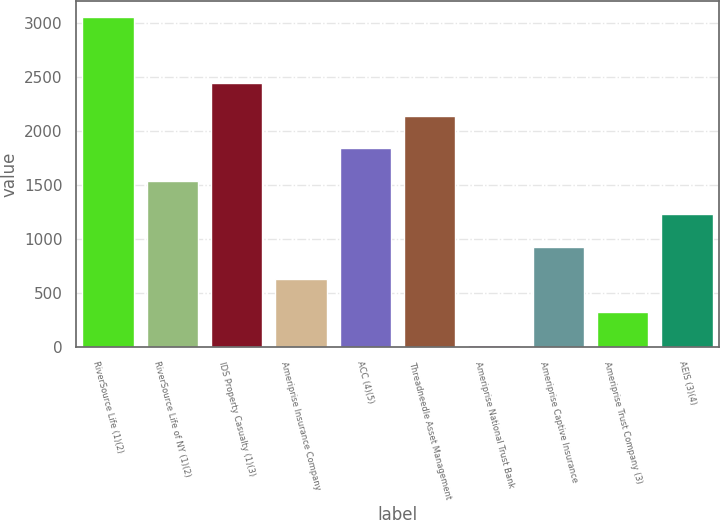<chart> <loc_0><loc_0><loc_500><loc_500><bar_chart><fcel>RiverSource Life (1)(2)<fcel>RiverSource Life of NY (1)(2)<fcel>IDS Property Casualty (1)(3)<fcel>Ameriprise Insurance Company<fcel>ACC (4)(5)<fcel>Threadneedle Asset Management<fcel>Ameriprise National Trust Bank<fcel>Ameriprise Captive Insurance<fcel>Ameriprise Trust Company (3)<fcel>AEIS (3)(4)<nl><fcel>3052<fcel>1537<fcel>2446<fcel>628<fcel>1840<fcel>2143<fcel>22<fcel>931<fcel>325<fcel>1234<nl></chart> 